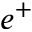<formula> <loc_0><loc_0><loc_500><loc_500>e ^ { + }</formula> 